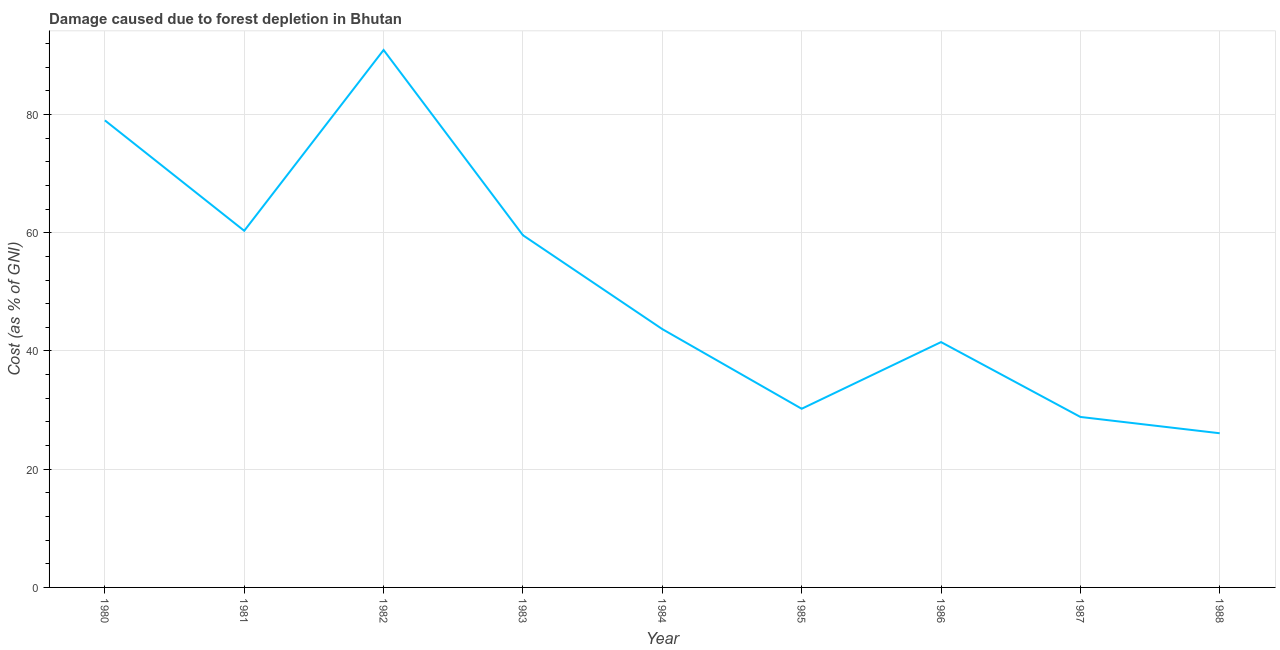What is the damage caused due to forest depletion in 1985?
Offer a terse response. 30.23. Across all years, what is the maximum damage caused due to forest depletion?
Offer a very short reply. 90.92. Across all years, what is the minimum damage caused due to forest depletion?
Offer a terse response. 26.08. In which year was the damage caused due to forest depletion minimum?
Offer a terse response. 1988. What is the sum of the damage caused due to forest depletion?
Your answer should be compact. 460.2. What is the difference between the damage caused due to forest depletion in 1981 and 1982?
Provide a succinct answer. -30.59. What is the average damage caused due to forest depletion per year?
Offer a very short reply. 51.13. What is the median damage caused due to forest depletion?
Make the answer very short. 43.7. Do a majority of the years between 1981 and 1987 (inclusive) have damage caused due to forest depletion greater than 72 %?
Keep it short and to the point. No. What is the ratio of the damage caused due to forest depletion in 1984 to that in 1985?
Your answer should be very brief. 1.45. Is the difference between the damage caused due to forest depletion in 1983 and 1984 greater than the difference between any two years?
Give a very brief answer. No. What is the difference between the highest and the second highest damage caused due to forest depletion?
Make the answer very short. 11.91. Is the sum of the damage caused due to forest depletion in 1981 and 1988 greater than the maximum damage caused due to forest depletion across all years?
Keep it short and to the point. No. What is the difference between the highest and the lowest damage caused due to forest depletion?
Provide a succinct answer. 64.84. In how many years, is the damage caused due to forest depletion greater than the average damage caused due to forest depletion taken over all years?
Your response must be concise. 4. How many lines are there?
Offer a very short reply. 1. What is the difference between two consecutive major ticks on the Y-axis?
Give a very brief answer. 20. Does the graph contain any zero values?
Offer a very short reply. No. Does the graph contain grids?
Your response must be concise. Yes. What is the title of the graph?
Keep it short and to the point. Damage caused due to forest depletion in Bhutan. What is the label or title of the X-axis?
Your answer should be compact. Year. What is the label or title of the Y-axis?
Keep it short and to the point. Cost (as % of GNI). What is the Cost (as % of GNI) in 1980?
Make the answer very short. 79.01. What is the Cost (as % of GNI) of 1981?
Give a very brief answer. 60.34. What is the Cost (as % of GNI) of 1982?
Ensure brevity in your answer.  90.92. What is the Cost (as % of GNI) in 1983?
Make the answer very short. 59.58. What is the Cost (as % of GNI) in 1984?
Your answer should be compact. 43.7. What is the Cost (as % of GNI) of 1985?
Offer a very short reply. 30.23. What is the Cost (as % of GNI) in 1986?
Make the answer very short. 41.51. What is the Cost (as % of GNI) of 1987?
Provide a succinct answer. 28.84. What is the Cost (as % of GNI) in 1988?
Give a very brief answer. 26.08. What is the difference between the Cost (as % of GNI) in 1980 and 1981?
Your response must be concise. 18.68. What is the difference between the Cost (as % of GNI) in 1980 and 1982?
Give a very brief answer. -11.91. What is the difference between the Cost (as % of GNI) in 1980 and 1983?
Offer a very short reply. 19.43. What is the difference between the Cost (as % of GNI) in 1980 and 1984?
Your answer should be compact. 35.31. What is the difference between the Cost (as % of GNI) in 1980 and 1985?
Make the answer very short. 48.79. What is the difference between the Cost (as % of GNI) in 1980 and 1986?
Ensure brevity in your answer.  37.51. What is the difference between the Cost (as % of GNI) in 1980 and 1987?
Make the answer very short. 50.17. What is the difference between the Cost (as % of GNI) in 1980 and 1988?
Your answer should be very brief. 52.93. What is the difference between the Cost (as % of GNI) in 1981 and 1982?
Ensure brevity in your answer.  -30.59. What is the difference between the Cost (as % of GNI) in 1981 and 1983?
Provide a succinct answer. 0.76. What is the difference between the Cost (as % of GNI) in 1981 and 1984?
Your response must be concise. 16.64. What is the difference between the Cost (as % of GNI) in 1981 and 1985?
Your answer should be compact. 30.11. What is the difference between the Cost (as % of GNI) in 1981 and 1986?
Your answer should be very brief. 18.83. What is the difference between the Cost (as % of GNI) in 1981 and 1987?
Give a very brief answer. 31.49. What is the difference between the Cost (as % of GNI) in 1981 and 1988?
Your answer should be compact. 34.25. What is the difference between the Cost (as % of GNI) in 1982 and 1983?
Ensure brevity in your answer.  31.34. What is the difference between the Cost (as % of GNI) in 1982 and 1984?
Provide a succinct answer. 47.22. What is the difference between the Cost (as % of GNI) in 1982 and 1985?
Your response must be concise. 60.7. What is the difference between the Cost (as % of GNI) in 1982 and 1986?
Make the answer very short. 49.42. What is the difference between the Cost (as % of GNI) in 1982 and 1987?
Make the answer very short. 62.08. What is the difference between the Cost (as % of GNI) in 1982 and 1988?
Offer a very short reply. 64.84. What is the difference between the Cost (as % of GNI) in 1983 and 1984?
Provide a short and direct response. 15.88. What is the difference between the Cost (as % of GNI) in 1983 and 1985?
Your response must be concise. 29.35. What is the difference between the Cost (as % of GNI) in 1983 and 1986?
Provide a succinct answer. 18.07. What is the difference between the Cost (as % of GNI) in 1983 and 1987?
Offer a very short reply. 30.74. What is the difference between the Cost (as % of GNI) in 1983 and 1988?
Ensure brevity in your answer.  33.5. What is the difference between the Cost (as % of GNI) in 1984 and 1985?
Provide a succinct answer. 13.47. What is the difference between the Cost (as % of GNI) in 1984 and 1986?
Keep it short and to the point. 2.19. What is the difference between the Cost (as % of GNI) in 1984 and 1987?
Your answer should be compact. 14.86. What is the difference between the Cost (as % of GNI) in 1984 and 1988?
Offer a very short reply. 17.62. What is the difference between the Cost (as % of GNI) in 1985 and 1986?
Offer a very short reply. -11.28. What is the difference between the Cost (as % of GNI) in 1985 and 1987?
Provide a short and direct response. 1.38. What is the difference between the Cost (as % of GNI) in 1985 and 1988?
Give a very brief answer. 4.14. What is the difference between the Cost (as % of GNI) in 1986 and 1987?
Your answer should be compact. 12.66. What is the difference between the Cost (as % of GNI) in 1986 and 1988?
Keep it short and to the point. 15.42. What is the difference between the Cost (as % of GNI) in 1987 and 1988?
Your answer should be compact. 2.76. What is the ratio of the Cost (as % of GNI) in 1980 to that in 1981?
Provide a succinct answer. 1.31. What is the ratio of the Cost (as % of GNI) in 1980 to that in 1982?
Ensure brevity in your answer.  0.87. What is the ratio of the Cost (as % of GNI) in 1980 to that in 1983?
Provide a short and direct response. 1.33. What is the ratio of the Cost (as % of GNI) in 1980 to that in 1984?
Your answer should be very brief. 1.81. What is the ratio of the Cost (as % of GNI) in 1980 to that in 1985?
Your answer should be very brief. 2.61. What is the ratio of the Cost (as % of GNI) in 1980 to that in 1986?
Your answer should be compact. 1.9. What is the ratio of the Cost (as % of GNI) in 1980 to that in 1987?
Your answer should be compact. 2.74. What is the ratio of the Cost (as % of GNI) in 1980 to that in 1988?
Offer a very short reply. 3.03. What is the ratio of the Cost (as % of GNI) in 1981 to that in 1982?
Your answer should be very brief. 0.66. What is the ratio of the Cost (as % of GNI) in 1981 to that in 1984?
Your answer should be very brief. 1.38. What is the ratio of the Cost (as % of GNI) in 1981 to that in 1985?
Make the answer very short. 2. What is the ratio of the Cost (as % of GNI) in 1981 to that in 1986?
Give a very brief answer. 1.45. What is the ratio of the Cost (as % of GNI) in 1981 to that in 1987?
Provide a succinct answer. 2.09. What is the ratio of the Cost (as % of GNI) in 1981 to that in 1988?
Your response must be concise. 2.31. What is the ratio of the Cost (as % of GNI) in 1982 to that in 1983?
Your response must be concise. 1.53. What is the ratio of the Cost (as % of GNI) in 1982 to that in 1984?
Make the answer very short. 2.08. What is the ratio of the Cost (as % of GNI) in 1982 to that in 1985?
Offer a very short reply. 3.01. What is the ratio of the Cost (as % of GNI) in 1982 to that in 1986?
Give a very brief answer. 2.19. What is the ratio of the Cost (as % of GNI) in 1982 to that in 1987?
Your answer should be very brief. 3.15. What is the ratio of the Cost (as % of GNI) in 1982 to that in 1988?
Offer a very short reply. 3.49. What is the ratio of the Cost (as % of GNI) in 1983 to that in 1984?
Offer a terse response. 1.36. What is the ratio of the Cost (as % of GNI) in 1983 to that in 1985?
Give a very brief answer. 1.97. What is the ratio of the Cost (as % of GNI) in 1983 to that in 1986?
Your response must be concise. 1.44. What is the ratio of the Cost (as % of GNI) in 1983 to that in 1987?
Provide a succinct answer. 2.07. What is the ratio of the Cost (as % of GNI) in 1983 to that in 1988?
Keep it short and to the point. 2.28. What is the ratio of the Cost (as % of GNI) in 1984 to that in 1985?
Keep it short and to the point. 1.45. What is the ratio of the Cost (as % of GNI) in 1984 to that in 1986?
Give a very brief answer. 1.05. What is the ratio of the Cost (as % of GNI) in 1984 to that in 1987?
Give a very brief answer. 1.51. What is the ratio of the Cost (as % of GNI) in 1984 to that in 1988?
Your response must be concise. 1.68. What is the ratio of the Cost (as % of GNI) in 1985 to that in 1986?
Your answer should be very brief. 0.73. What is the ratio of the Cost (as % of GNI) in 1985 to that in 1987?
Give a very brief answer. 1.05. What is the ratio of the Cost (as % of GNI) in 1985 to that in 1988?
Offer a very short reply. 1.16. What is the ratio of the Cost (as % of GNI) in 1986 to that in 1987?
Provide a short and direct response. 1.44. What is the ratio of the Cost (as % of GNI) in 1986 to that in 1988?
Provide a succinct answer. 1.59. What is the ratio of the Cost (as % of GNI) in 1987 to that in 1988?
Offer a very short reply. 1.11. 